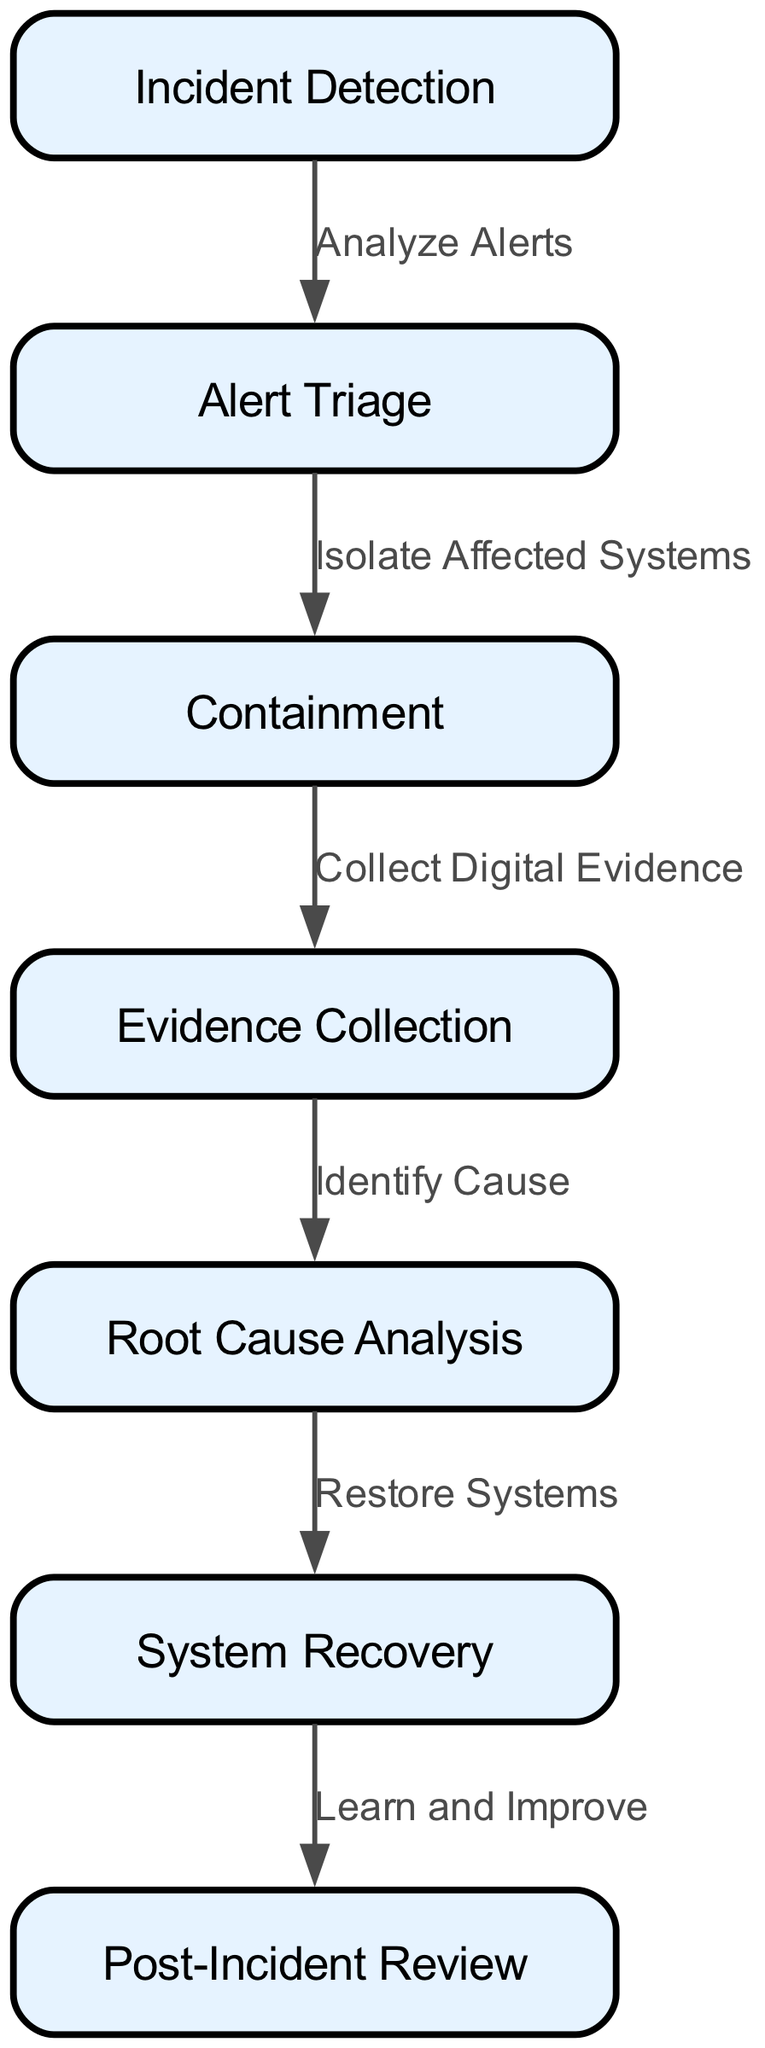How many nodes are in the diagram? The diagram contains a total of seven distinct nodes that represent various stages of the cybersecurity incident response plan. Each node corresponds to a specific function within the overall process.
Answer: 7 What is the first stage in the incident response process? The first stage in the incident response process is represented by the node labeled "Incident Detection," which serves as the starting point for recognizing potential cybersecurity incidents.
Answer: Incident Detection What action follows "Alert Triage"? The action that follows "Alert Triage" is "Containment," which involves isolating affected systems to prevent further damage from the cybersecurity incident.
Answer: Containment Which node comes before "Root Cause Analysis"? The node that comes directly before "Root Cause Analysis" is "Evidence Collection," which is focused on gathering digital evidence needed to understand the incident.
Answer: Evidence Collection What is the final step in the incident response plan? The final step in the incident response plan is "Post-Incident Review," which is aimed at learning from the incident to improve future response efforts.
Answer: Post-Incident Review What label connects "Containment" and "Evidence Collection"? The label that connects "Containment" and "Evidence Collection" is "Collect Digital Evidence," indicating the action taken to gather necessary information for analysis after containment is implemented.
Answer: Collect Digital Evidence Which step directly leads to system restoration and recovery? The step that directly leads to system restoration and recovery is "Root Cause Analysis," as understanding the cause of the incident is critical before efforts to restore systems can take place.
Answer: Root Cause Analysis What type of diagram is used to represent the cybersecurity incident response plan? The type of diagram used to represent the cybersecurity incident response plan is a block diagram, which visually illustrates the sequential flow of actions and decisions in the response process.
Answer: Block Diagram 